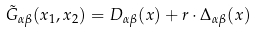<formula> <loc_0><loc_0><loc_500><loc_500>\tilde { G } _ { \alpha \beta } ( { x } _ { 1 } , { x } _ { 2 } ) = D _ { \alpha \beta } ( x ) + { r } \cdot { \Delta } _ { \alpha \beta } ( x )</formula> 